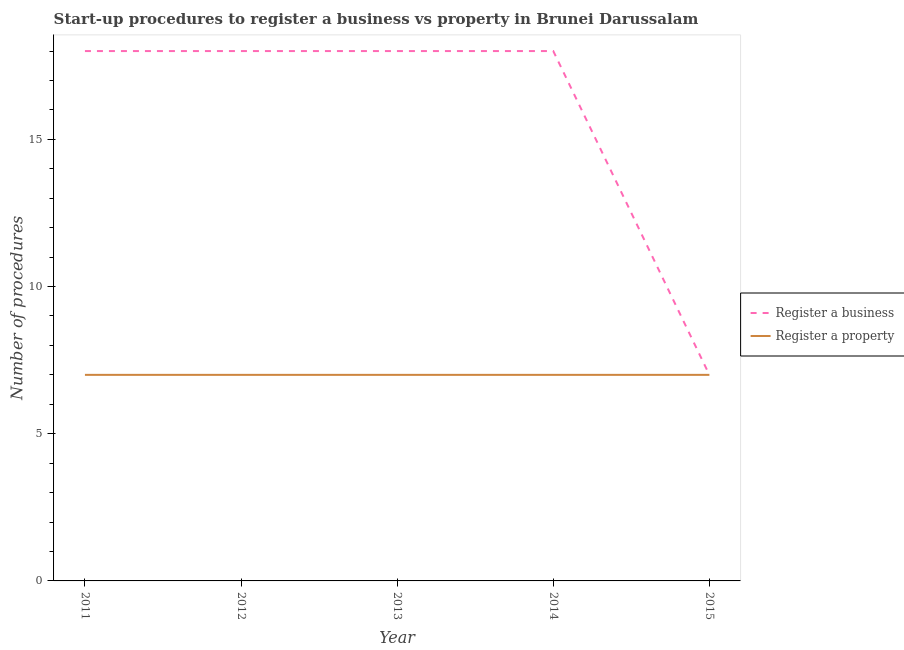How many different coloured lines are there?
Offer a very short reply. 2. Does the line corresponding to number of procedures to register a property intersect with the line corresponding to number of procedures to register a business?
Ensure brevity in your answer.  Yes. What is the number of procedures to register a business in 2013?
Ensure brevity in your answer.  18. Across all years, what is the maximum number of procedures to register a property?
Give a very brief answer. 7. Across all years, what is the minimum number of procedures to register a property?
Your answer should be very brief. 7. What is the total number of procedures to register a business in the graph?
Make the answer very short. 79. What is the difference between the number of procedures to register a business in 2012 and the number of procedures to register a property in 2013?
Provide a short and direct response. 11. In the year 2014, what is the difference between the number of procedures to register a property and number of procedures to register a business?
Provide a succinct answer. -11. In how many years, is the number of procedures to register a property greater than 10?
Your answer should be compact. 0. What is the ratio of the number of procedures to register a property in 2014 to that in 2015?
Offer a terse response. 1. Is the difference between the number of procedures to register a property in 2014 and 2015 greater than the difference between the number of procedures to register a business in 2014 and 2015?
Keep it short and to the point. No. What is the difference between the highest and the second highest number of procedures to register a business?
Give a very brief answer. 0. What is the difference between the highest and the lowest number of procedures to register a business?
Offer a terse response. 11. Is the number of procedures to register a property strictly greater than the number of procedures to register a business over the years?
Your answer should be compact. No. Is the number of procedures to register a business strictly less than the number of procedures to register a property over the years?
Provide a short and direct response. No. How many years are there in the graph?
Your answer should be very brief. 5. What is the difference between two consecutive major ticks on the Y-axis?
Give a very brief answer. 5. Are the values on the major ticks of Y-axis written in scientific E-notation?
Your response must be concise. No. Does the graph contain any zero values?
Your answer should be compact. No. Does the graph contain grids?
Keep it short and to the point. No. What is the title of the graph?
Keep it short and to the point. Start-up procedures to register a business vs property in Brunei Darussalam. What is the label or title of the Y-axis?
Offer a very short reply. Number of procedures. What is the Number of procedures in Register a business in 2012?
Offer a terse response. 18. What is the Number of procedures in Register a property in 2012?
Your answer should be very brief. 7. What is the Number of procedures of Register a business in 2013?
Offer a terse response. 18. What is the Number of procedures in Register a property in 2015?
Give a very brief answer. 7. Across all years, what is the maximum Number of procedures of Register a property?
Keep it short and to the point. 7. What is the total Number of procedures in Register a business in the graph?
Keep it short and to the point. 79. What is the difference between the Number of procedures of Register a property in 2011 and that in 2012?
Provide a succinct answer. 0. What is the difference between the Number of procedures in Register a business in 2011 and that in 2014?
Your answer should be very brief. 0. What is the difference between the Number of procedures in Register a property in 2011 and that in 2014?
Provide a short and direct response. 0. What is the difference between the Number of procedures of Register a business in 2012 and that in 2013?
Provide a short and direct response. 0. What is the difference between the Number of procedures in Register a property in 2012 and that in 2015?
Offer a very short reply. 0. What is the difference between the Number of procedures in Register a property in 2013 and that in 2014?
Offer a terse response. 0. What is the difference between the Number of procedures in Register a business in 2013 and that in 2015?
Your answer should be compact. 11. What is the difference between the Number of procedures in Register a property in 2013 and that in 2015?
Make the answer very short. 0. What is the difference between the Number of procedures of Register a property in 2014 and that in 2015?
Provide a succinct answer. 0. What is the difference between the Number of procedures in Register a business in 2011 and the Number of procedures in Register a property in 2012?
Give a very brief answer. 11. What is the difference between the Number of procedures in Register a business in 2011 and the Number of procedures in Register a property in 2013?
Your answer should be very brief. 11. What is the difference between the Number of procedures of Register a business in 2011 and the Number of procedures of Register a property in 2015?
Your response must be concise. 11. What is the difference between the Number of procedures of Register a business in 2012 and the Number of procedures of Register a property in 2013?
Keep it short and to the point. 11. What is the difference between the Number of procedures in Register a business in 2012 and the Number of procedures in Register a property in 2014?
Give a very brief answer. 11. What is the difference between the Number of procedures in Register a business in 2012 and the Number of procedures in Register a property in 2015?
Your answer should be very brief. 11. What is the difference between the Number of procedures of Register a business in 2013 and the Number of procedures of Register a property in 2014?
Keep it short and to the point. 11. What is the average Number of procedures of Register a property per year?
Provide a short and direct response. 7. In the year 2011, what is the difference between the Number of procedures in Register a business and Number of procedures in Register a property?
Your answer should be compact. 11. In the year 2012, what is the difference between the Number of procedures in Register a business and Number of procedures in Register a property?
Your answer should be very brief. 11. In the year 2013, what is the difference between the Number of procedures of Register a business and Number of procedures of Register a property?
Make the answer very short. 11. In the year 2014, what is the difference between the Number of procedures of Register a business and Number of procedures of Register a property?
Your answer should be compact. 11. What is the ratio of the Number of procedures of Register a business in 2011 to that in 2012?
Give a very brief answer. 1. What is the ratio of the Number of procedures of Register a business in 2011 to that in 2013?
Your answer should be very brief. 1. What is the ratio of the Number of procedures in Register a property in 2011 to that in 2013?
Ensure brevity in your answer.  1. What is the ratio of the Number of procedures of Register a business in 2011 to that in 2014?
Provide a succinct answer. 1. What is the ratio of the Number of procedures in Register a property in 2011 to that in 2014?
Your answer should be very brief. 1. What is the ratio of the Number of procedures of Register a business in 2011 to that in 2015?
Ensure brevity in your answer.  2.57. What is the ratio of the Number of procedures in Register a property in 2011 to that in 2015?
Provide a succinct answer. 1. What is the ratio of the Number of procedures in Register a business in 2012 to that in 2013?
Ensure brevity in your answer.  1. What is the ratio of the Number of procedures in Register a property in 2012 to that in 2013?
Give a very brief answer. 1. What is the ratio of the Number of procedures in Register a business in 2012 to that in 2014?
Provide a short and direct response. 1. What is the ratio of the Number of procedures of Register a property in 2012 to that in 2014?
Keep it short and to the point. 1. What is the ratio of the Number of procedures of Register a business in 2012 to that in 2015?
Make the answer very short. 2.57. What is the ratio of the Number of procedures of Register a business in 2013 to that in 2015?
Provide a short and direct response. 2.57. What is the ratio of the Number of procedures of Register a business in 2014 to that in 2015?
Your response must be concise. 2.57. What is the ratio of the Number of procedures in Register a property in 2014 to that in 2015?
Keep it short and to the point. 1. What is the difference between the highest and the second highest Number of procedures in Register a property?
Give a very brief answer. 0. What is the difference between the highest and the lowest Number of procedures of Register a business?
Ensure brevity in your answer.  11. What is the difference between the highest and the lowest Number of procedures in Register a property?
Provide a short and direct response. 0. 